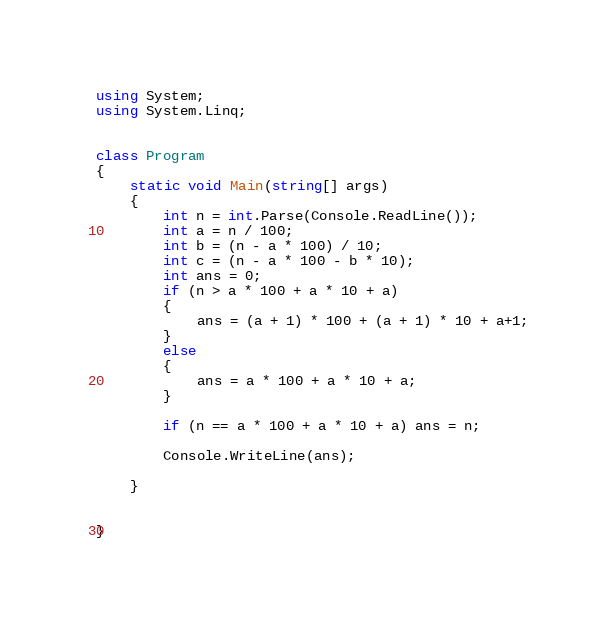Convert code to text. <code><loc_0><loc_0><loc_500><loc_500><_C#_>using System;
using System.Linq;


class Program
{
    static void Main(string[] args)
    {
        int n = int.Parse(Console.ReadLine());
        int a = n / 100;
        int b = (n - a * 100) / 10;
        int c = (n - a * 100 - b * 10);
        int ans = 0;
        if (n > a * 100 + a * 10 + a)
        {
            ans = (a + 1) * 100 + (a + 1) * 10 + a+1;
        }
        else
        {
            ans = a * 100 + a * 10 + a;
        }

        if (n == a * 100 + a * 10 + a) ans = n;
        
        Console.WriteLine(ans);
        
    }


}</code> 